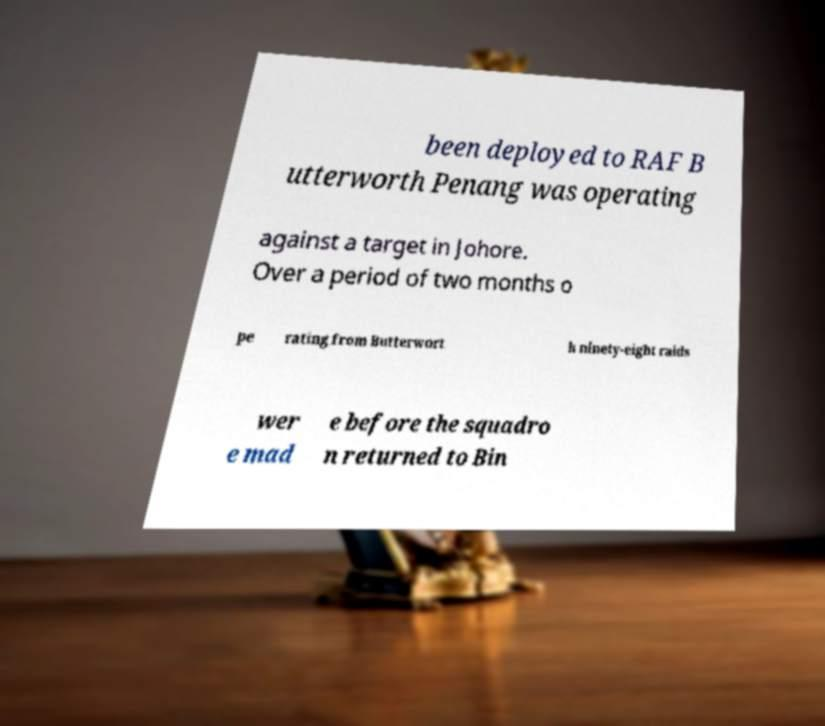I need the written content from this picture converted into text. Can you do that? been deployed to RAF B utterworth Penang was operating against a target in Johore. Over a period of two months o pe rating from Butterwort h ninety-eight raids wer e mad e before the squadro n returned to Bin 